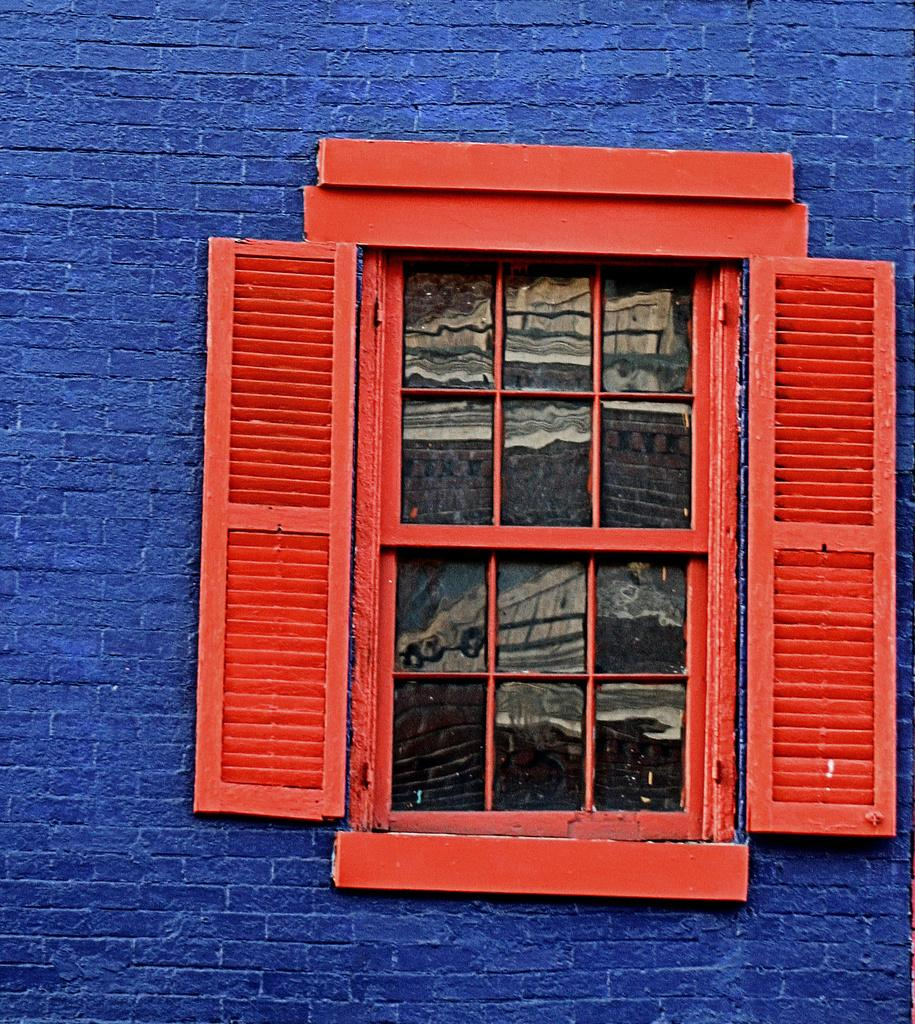What color is the wall in the image? The wall in the image is big and blue. What type of window is present in the image? There is a red wooden window with glass in the image. How does the crowd interact with the brain in the image? There is no crowd or brain present in the image; it only features a big blue wall and a red wooden window with glass. 